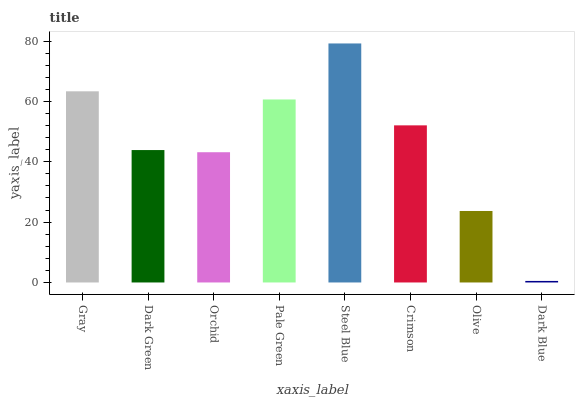Is Dark Blue the minimum?
Answer yes or no. Yes. Is Steel Blue the maximum?
Answer yes or no. Yes. Is Dark Green the minimum?
Answer yes or no. No. Is Dark Green the maximum?
Answer yes or no. No. Is Gray greater than Dark Green?
Answer yes or no. Yes. Is Dark Green less than Gray?
Answer yes or no. Yes. Is Dark Green greater than Gray?
Answer yes or no. No. Is Gray less than Dark Green?
Answer yes or no. No. Is Crimson the high median?
Answer yes or no. Yes. Is Dark Green the low median?
Answer yes or no. Yes. Is Pale Green the high median?
Answer yes or no. No. Is Orchid the low median?
Answer yes or no. No. 